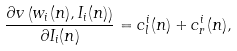Convert formula to latex. <formula><loc_0><loc_0><loc_500><loc_500>\frac { \partial v \left ( w _ { i } ( n ) , I _ { i } ( n ) \right ) } { \partial I _ { i } ( n ) } = c ^ { i } _ { l } ( n ) + c ^ { i } _ { r } ( n ) ,</formula> 